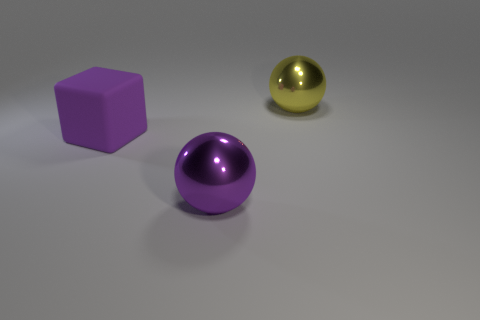Add 1 big brown shiny spheres. How many objects exist? 4 Subtract all spheres. How many objects are left? 1 Add 2 large spheres. How many large spheres are left? 4 Add 2 large purple cubes. How many large purple cubes exist? 3 Subtract 0 green cylinders. How many objects are left? 3 Subtract all blue metal blocks. Subtract all purple cubes. How many objects are left? 2 